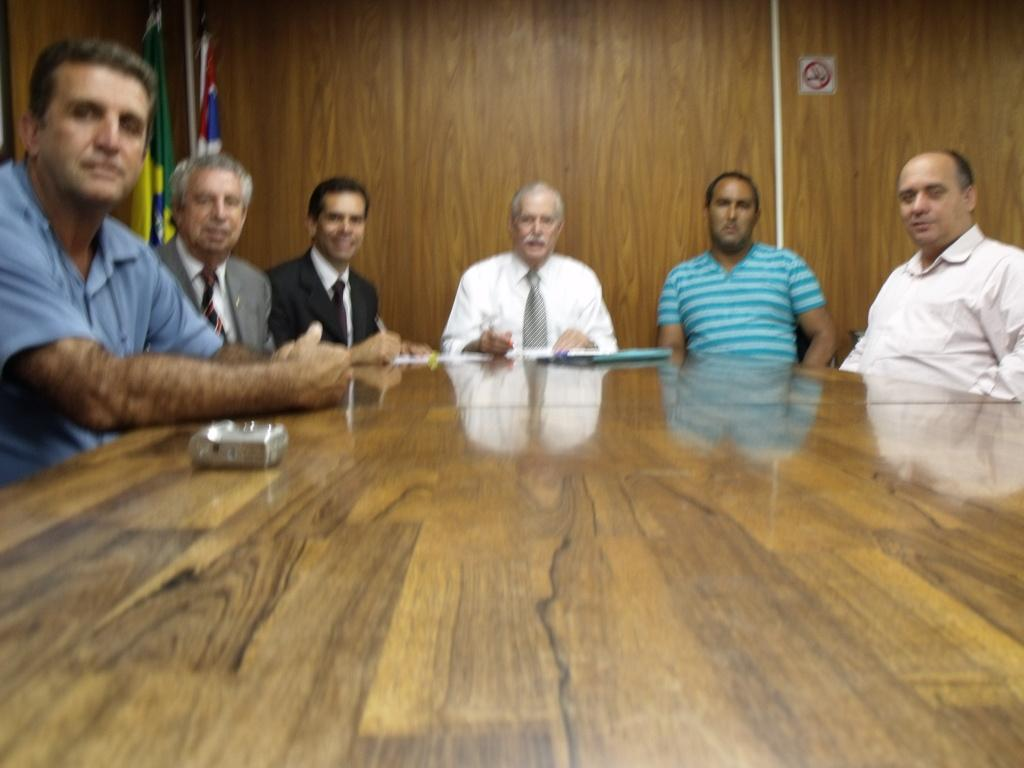What are the people in the image doing? The people in the image are sitting on chairs. How are the chairs arranged in relation to each other? The chairs are arranged around a table. What can be seen in the background of the image? There are two flags visible in the background. What type of quill is being used by the people sitting on chairs in the image? There is no quill present in the image; the people are simply sitting on chairs. 